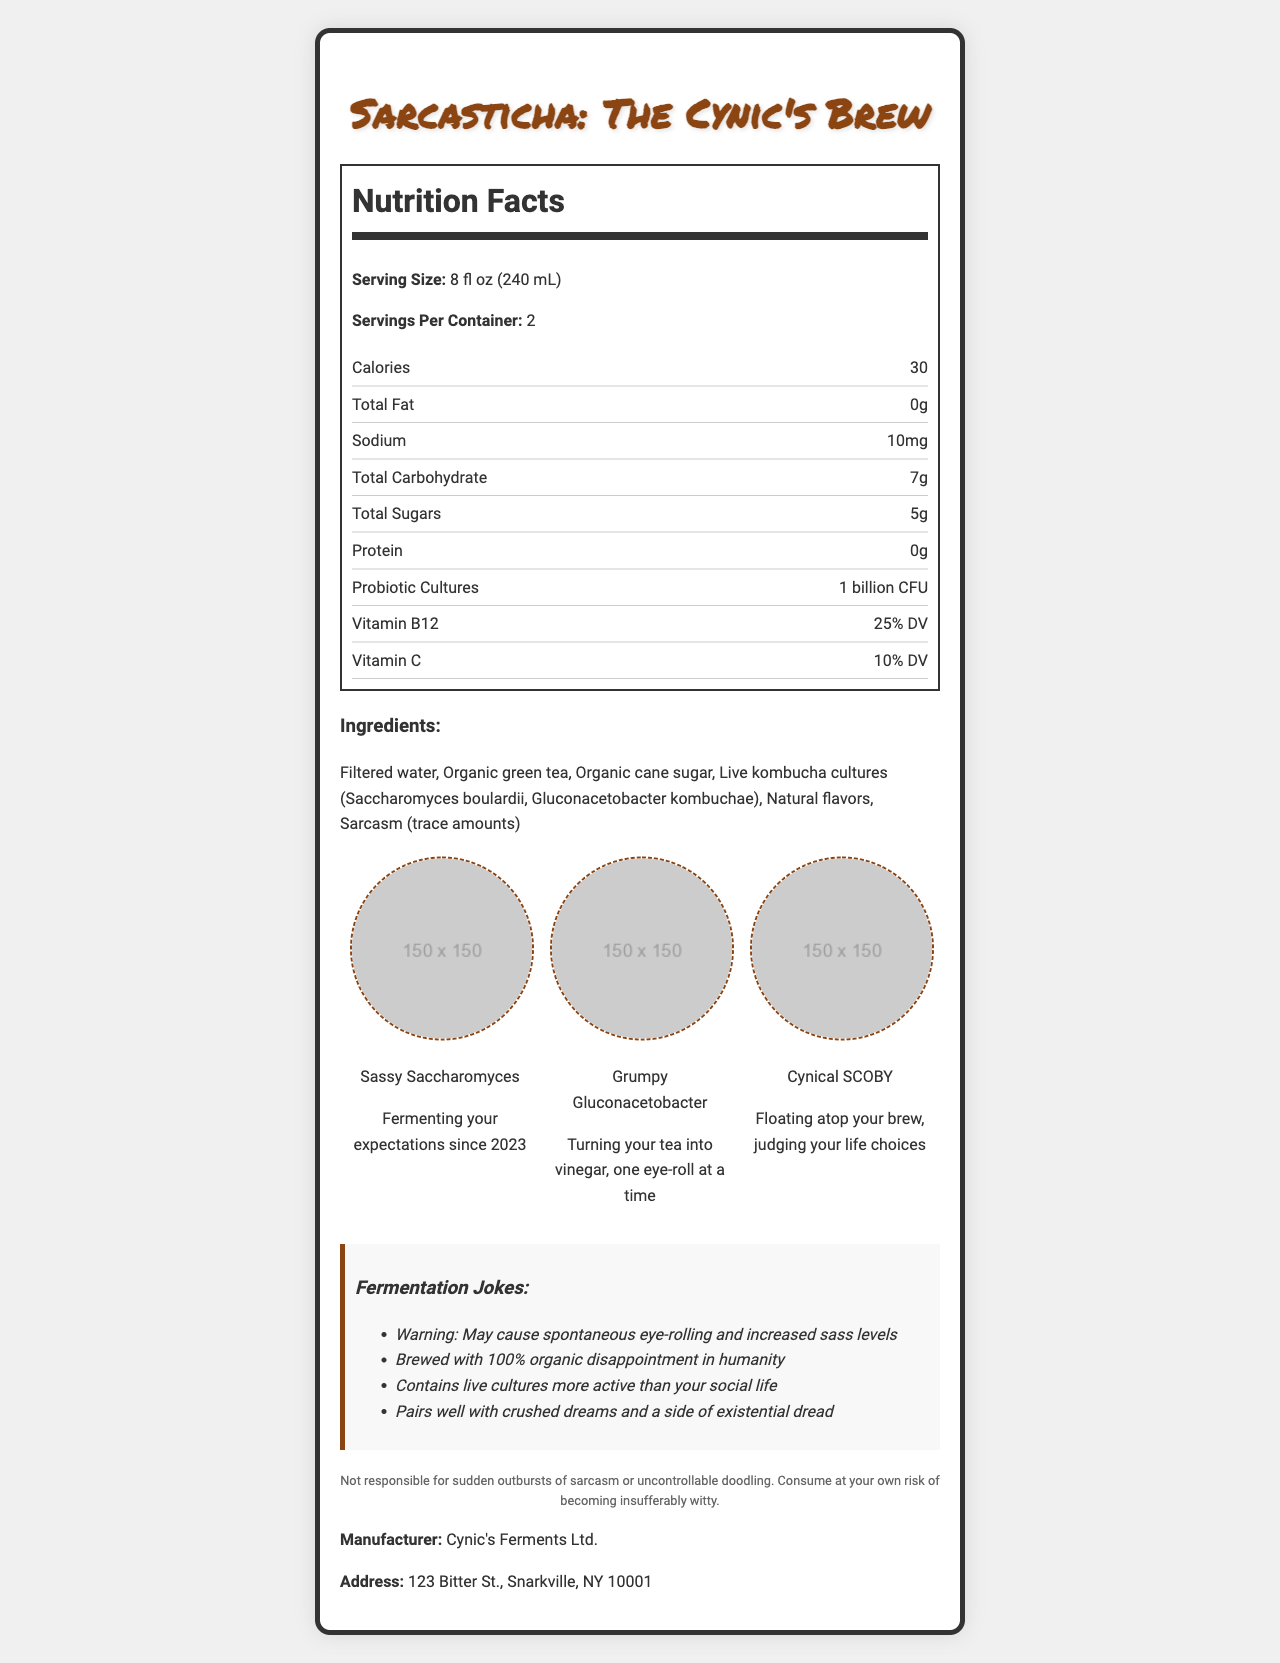what is the serving size? The serving size is listed near the top of the nutrition label under "Serving Size."
Answer: 8 fl oz (240 mL) how many servings per container are there? The number of servings per container is specified directly below the serving size.
Answer: 2 what are the total calories per serving? The total calories per serving is displayed right under the "Calories" section of the nutrition label.
Answer: 30 calories how much total fat is in one serving? The amount of total fat per serving is listed as "0g" in the nutrition label.
Answer: 0g what is the amount of probiotic cultures in the kombucha? The amount of probiotic cultures is listed under "Probiotic Cultures" in the nutrition label.
Answer: 1 billion CFU how much sugar does one serving contain? A. 10g B. 5g C. 7g D. 0g The total sugars per serving is stated as "5g" in the nutrition label.
Answer: B. 5g what is the percentage of Vitamin B12 in this beverage? A. 10% DV B. 25% DV C. 50% DV D. 75% DV The amount of Vitamin B12 per serving is indicated as "25% DV" in the nutrition label.
Answer: B. 25% DV does the kombucha contain protein? The nutrition label shows "Protein" as "0g," indicating there is no protein in the beverage.
Answer: No what are the primary ingredients in the kombucha? This list is displayed in the ingredients section of the document.
Answer: Filtered water, Organic green tea, Organic cane sugar, Live kombucha cultures, Natural flavors, Sarcasm (trace amounts) how many different microbe doodles are illustrated on the label? There are three illustrated microbe doodles named "Sassy Saccharomyces," "Grumpy Gluconacetobacter," and "Cynical SCOBY" as shown in the doodles section.
Answer: 3 which of the following is NOT a fermentation joke listed? A. "Warning: May cause spontaneous eye-rolling and increased sass levels" B. "Brewed with 100% organic disappointment in humanity" C. "May improve your humor beyond your wildest dreams" D. "Contains live cultures more active than your social life" "May improve your humor beyond your wildest dreams" is not listed in the fermentation jokes section.
Answer: C. "May improve your humor beyond your wildest dreams" how much sodium is in a serving of this kombucha? The sodium content per serving is given as "10mg" in the nutrition facts section.
Answer: 10mg what is the main idea of this document? The document lists nutritional information, ingredients, illustrates microbe doodles, includes fermentation jokes, and provides a disclaimer.
Answer: This document provides the nutrition facts, ingredients, and humorous elements related to "Sarcasticha: The Cynic's Brew" Kombucha. what is the exact address of the manufacturer? The manufacturer's address is specified at the bottom of the document under "Manufacturer."
Answer: 123 Bitter St., Snarkville, NY 10001 what year is mentioned in the doodle captions? "Fermenting your expectations since 2023" is part of the caption for Sassy Saccharomyces.
Answer: 2023 what is the total carbohydrate content for the entire bottle? Since there are 2 servings per container and each serving has 7g of total carbohydrates, the entire bottle contains 14g of carbohydrates when you multiply 7g by 2.
Answer: 14g is the drink suitable for people looking to increase their protein intake? The nutrition label shows that the drink contains 0g of protein.
Answer: No who is the manufacturer of Sarcasticha? The manufacturer's name is given towards the bottom of the document.
Answer: Cynic's Ferments Ltd. what is the origin of the natural flavors used in this kombucha? The document does not specify the origin of the natural flavors.
Answer: Not enough information 